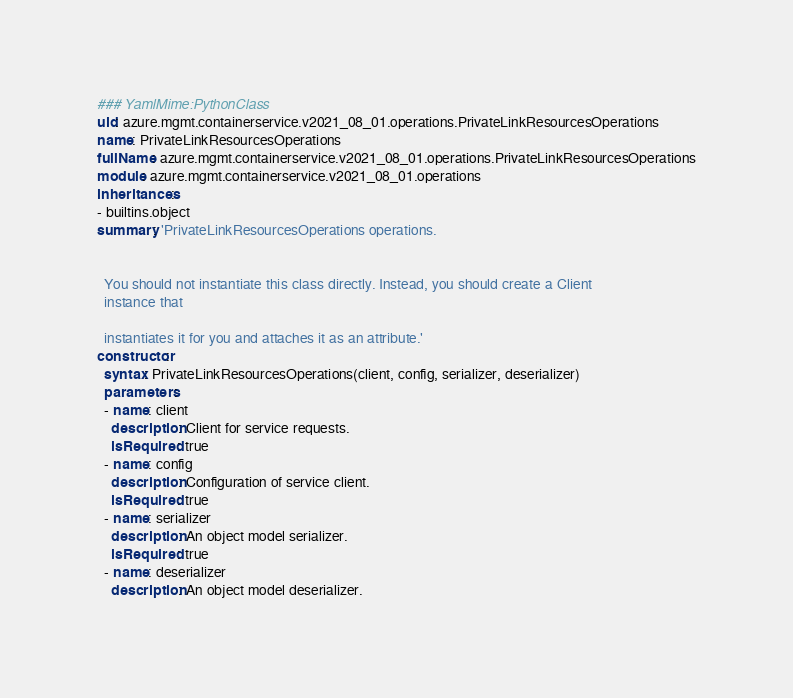Convert code to text. <code><loc_0><loc_0><loc_500><loc_500><_YAML_>### YamlMime:PythonClass
uid: azure.mgmt.containerservice.v2021_08_01.operations.PrivateLinkResourcesOperations
name: PrivateLinkResourcesOperations
fullName: azure.mgmt.containerservice.v2021_08_01.operations.PrivateLinkResourcesOperations
module: azure.mgmt.containerservice.v2021_08_01.operations
inheritances:
- builtins.object
summary: 'PrivateLinkResourcesOperations operations.


  You should not instantiate this class directly. Instead, you should create a Client
  instance that

  instantiates it for you and attaches it as an attribute.'
constructor:
  syntax: PrivateLinkResourcesOperations(client, config, serializer, deserializer)
  parameters:
  - name: client
    description: Client for service requests.
    isRequired: true
  - name: config
    description: Configuration of service client.
    isRequired: true
  - name: serializer
    description: An object model serializer.
    isRequired: true
  - name: deserializer
    description: An object model deserializer.</code> 